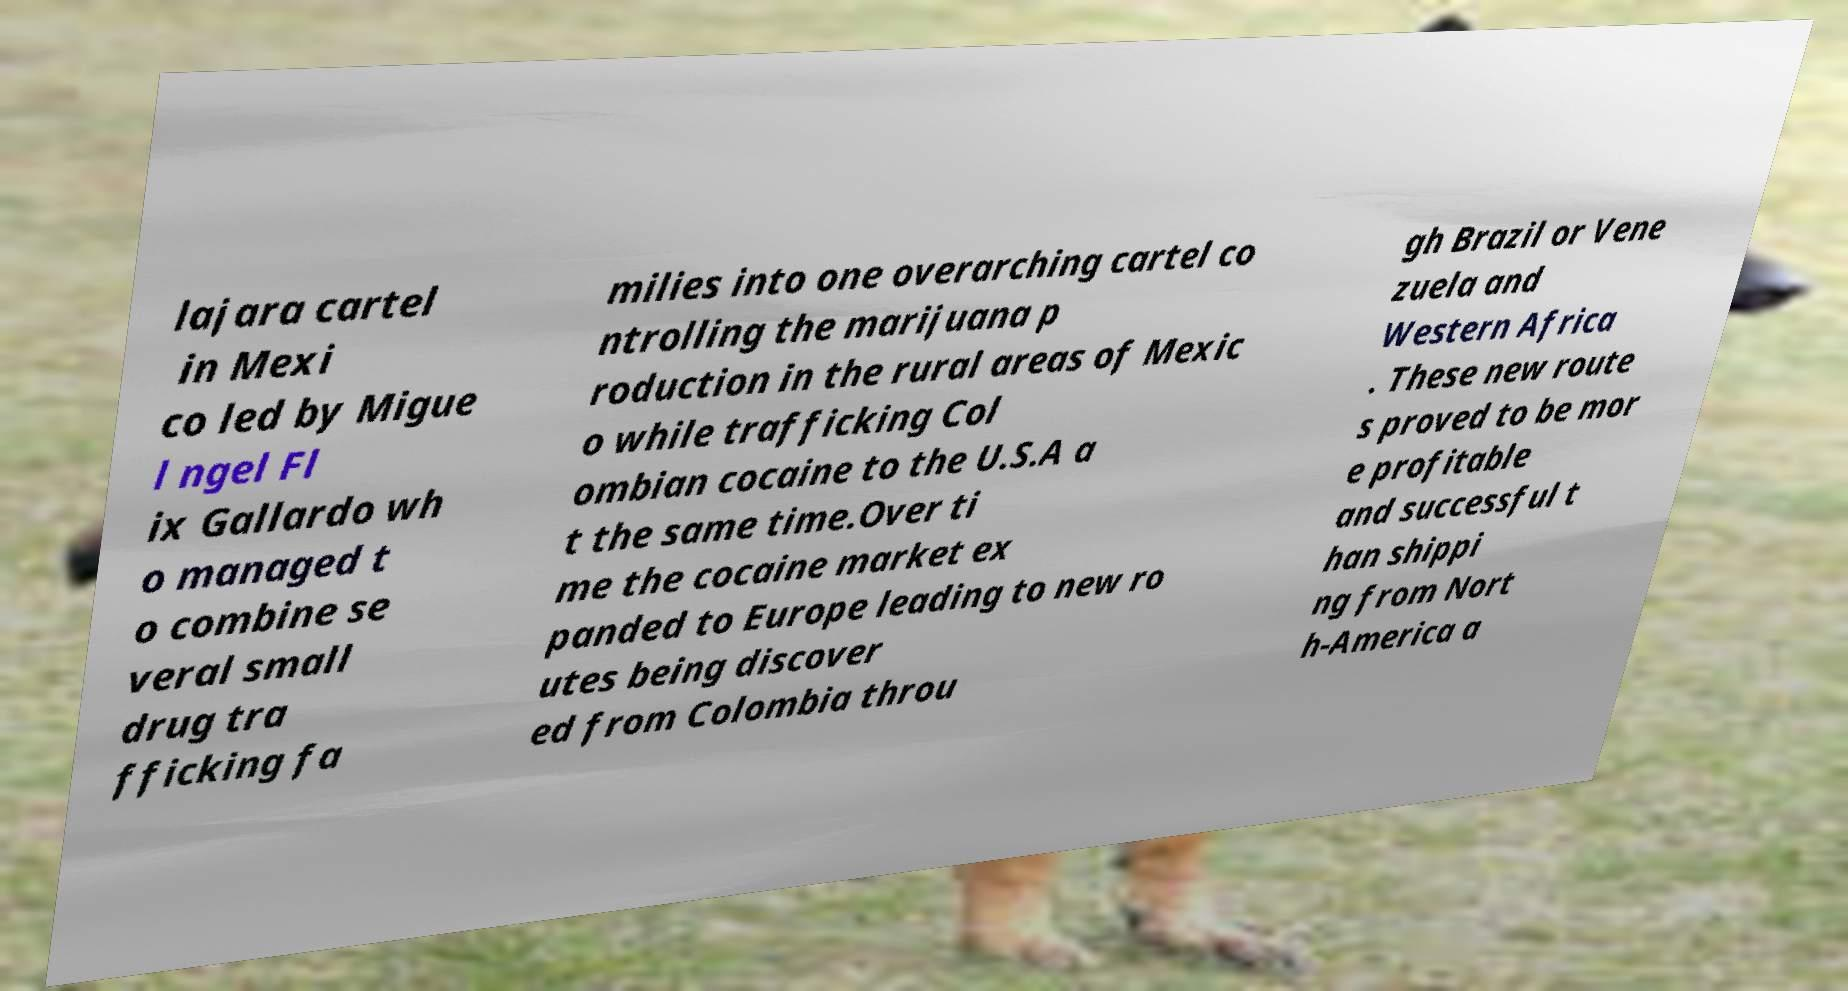Could you extract and type out the text from this image? lajara cartel in Mexi co led by Migue l ngel Fl ix Gallardo wh o managed t o combine se veral small drug tra fficking fa milies into one overarching cartel co ntrolling the marijuana p roduction in the rural areas of Mexic o while trafficking Col ombian cocaine to the U.S.A a t the same time.Over ti me the cocaine market ex panded to Europe leading to new ro utes being discover ed from Colombia throu gh Brazil or Vene zuela and Western Africa . These new route s proved to be mor e profitable and successful t han shippi ng from Nort h-America a 